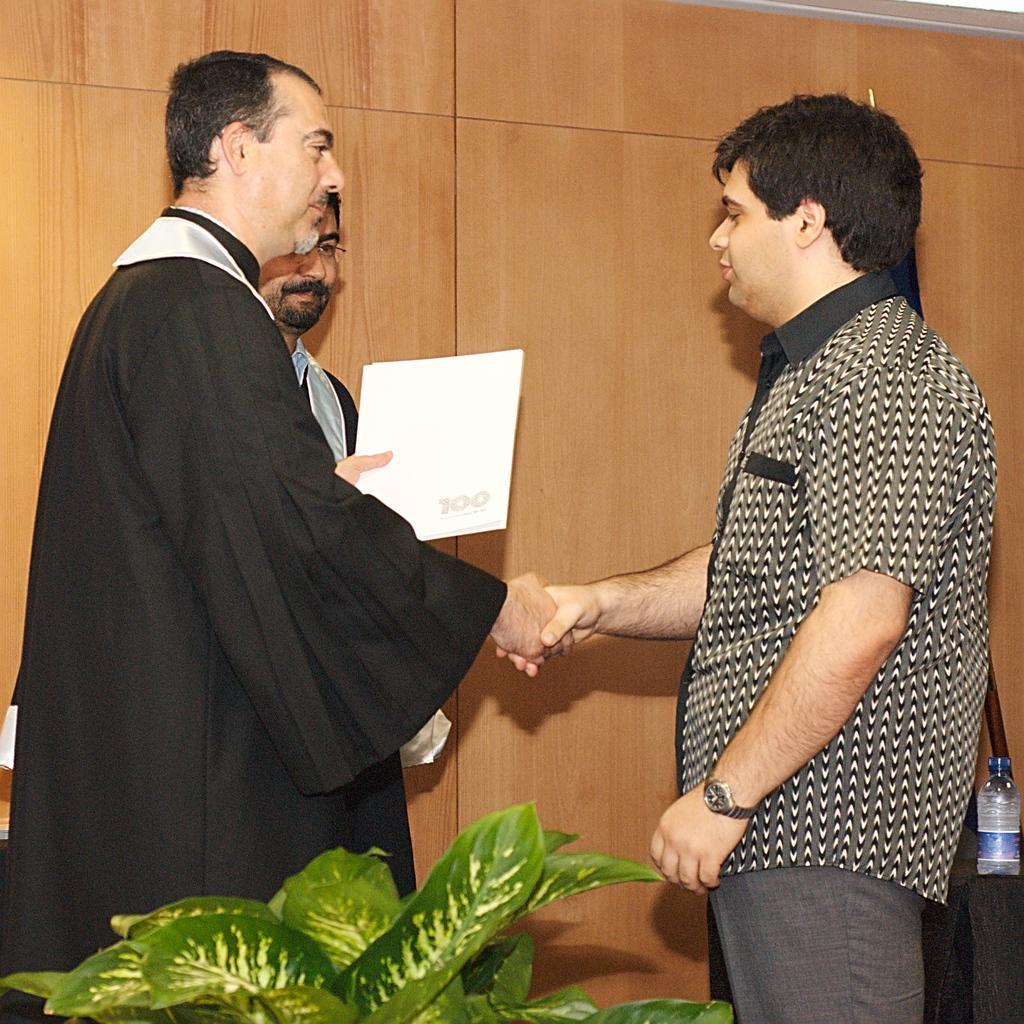Describe this image in one or two sentences. In this image, we can see three persons. Here two men are shaking their hands with each other. Here a person holding a white object. At the bottom, we can see plant leaves. On the right side of the image, we can see black cloth and bottle. Background we can see wooden wall. 